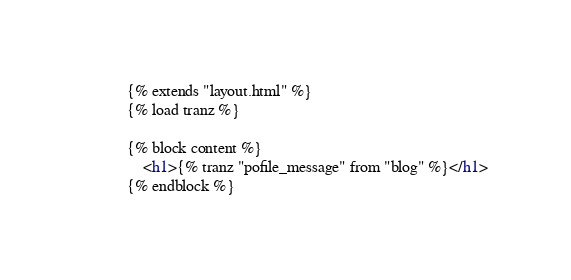<code> <loc_0><loc_0><loc_500><loc_500><_HTML_>{% extends "layout.html" %}
{% load tranz %}

{% block content %}
    <h1>{% tranz "pofile_message" from "blog" %}</h1>
{% endblock %}</code> 